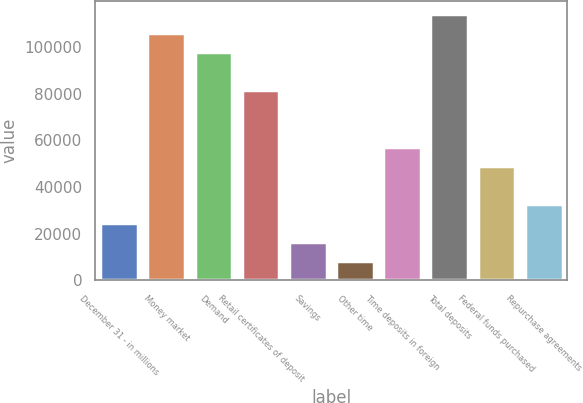Convert chart to OTSL. <chart><loc_0><loc_0><loc_500><loc_500><bar_chart><fcel>December 31 - in millions<fcel>Money market<fcel>Demand<fcel>Retail certificates of deposit<fcel>Savings<fcel>Other time<fcel>Time deposits in foreign<fcel>Total deposits<fcel>Federal funds purchased<fcel>Repurchase agreements<nl><fcel>24428.1<fcel>105715<fcel>97586.4<fcel>81329<fcel>16299.4<fcel>8170.7<fcel>56942.9<fcel>113844<fcel>48814.2<fcel>32556.8<nl></chart> 